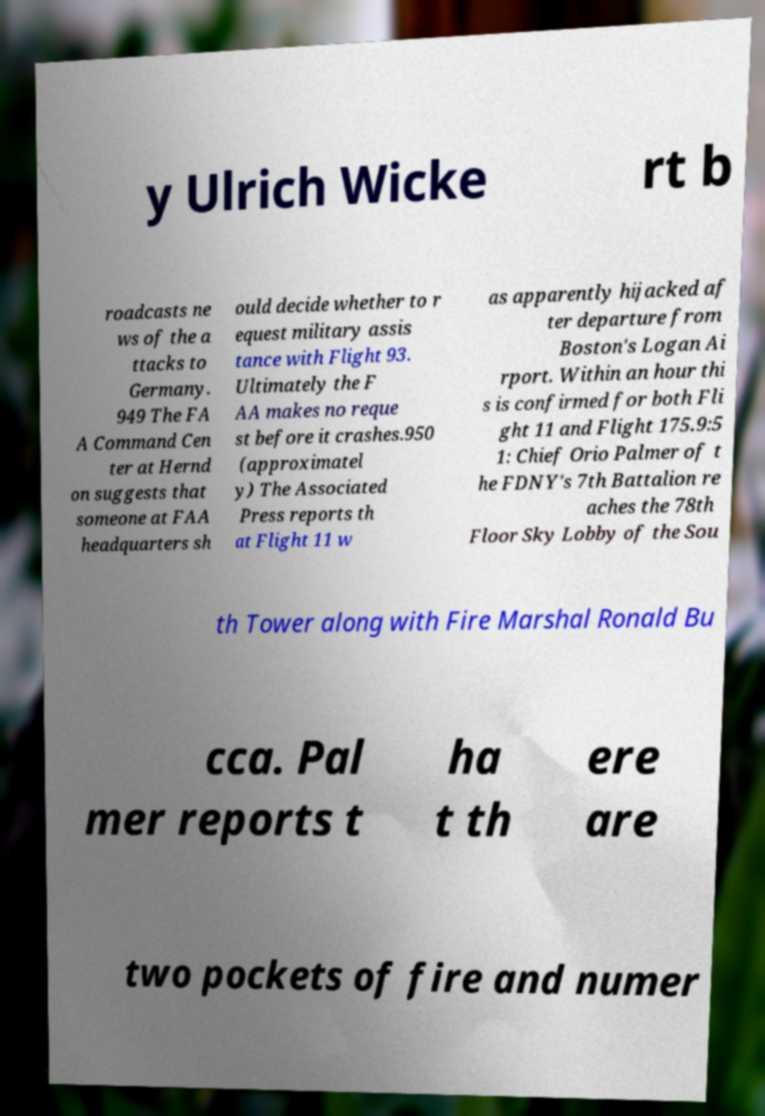What messages or text are displayed in this image? I need them in a readable, typed format. y Ulrich Wicke rt b roadcasts ne ws of the a ttacks to Germany. 949 The FA A Command Cen ter at Hernd on suggests that someone at FAA headquarters sh ould decide whether to r equest military assis tance with Flight 93. Ultimately the F AA makes no reque st before it crashes.950 (approximatel y) The Associated Press reports th at Flight 11 w as apparently hijacked af ter departure from Boston's Logan Ai rport. Within an hour thi s is confirmed for both Fli ght 11 and Flight 175.9:5 1: Chief Orio Palmer of t he FDNY's 7th Battalion re aches the 78th Floor Sky Lobby of the Sou th Tower along with Fire Marshal Ronald Bu cca. Pal mer reports t ha t th ere are two pockets of fire and numer 